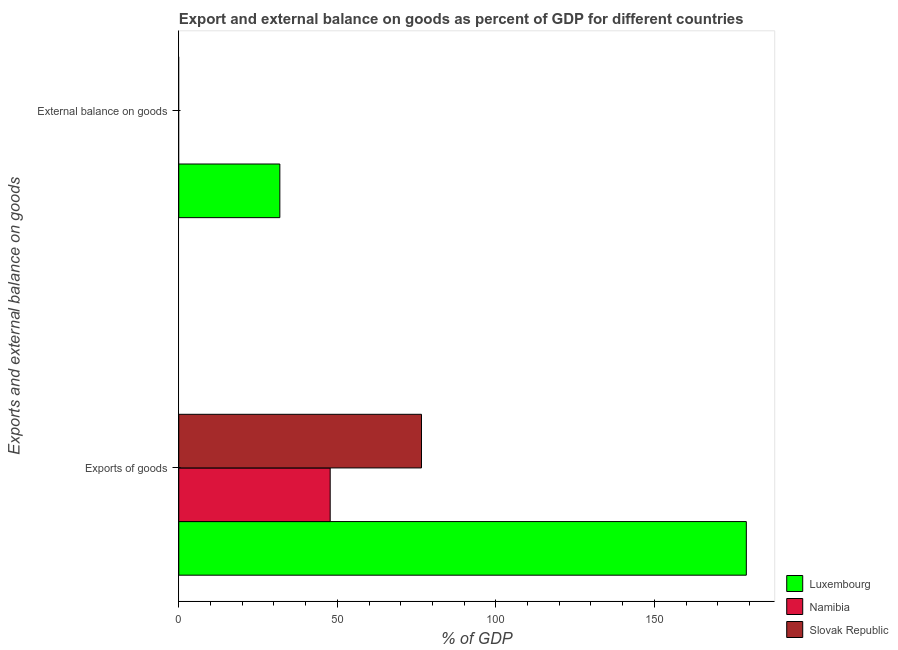Are the number of bars on each tick of the Y-axis equal?
Make the answer very short. No. How many bars are there on the 2nd tick from the top?
Keep it short and to the point. 3. What is the label of the 1st group of bars from the top?
Your answer should be compact. External balance on goods. What is the export of goods as percentage of gdp in Slovak Republic?
Offer a very short reply. 76.55. Across all countries, what is the maximum external balance on goods as percentage of gdp?
Offer a very short reply. 31.88. Across all countries, what is the minimum external balance on goods as percentage of gdp?
Provide a short and direct response. 0. In which country was the export of goods as percentage of gdp maximum?
Your answer should be very brief. Luxembourg. What is the total export of goods as percentage of gdp in the graph?
Your answer should be very brief. 303.32. What is the difference between the export of goods as percentage of gdp in Slovak Republic and that in Luxembourg?
Your answer should be compact. -102.46. What is the difference between the external balance on goods as percentage of gdp in Luxembourg and the export of goods as percentage of gdp in Namibia?
Provide a short and direct response. -15.88. What is the average export of goods as percentage of gdp per country?
Provide a short and direct response. 101.11. What is the difference between the external balance on goods as percentage of gdp and export of goods as percentage of gdp in Luxembourg?
Give a very brief answer. -147.13. What is the ratio of the export of goods as percentage of gdp in Slovak Republic to that in Namibia?
Give a very brief answer. 1.6. Is the export of goods as percentage of gdp in Namibia less than that in Luxembourg?
Your response must be concise. Yes. Are all the bars in the graph horizontal?
Give a very brief answer. Yes. Are the values on the major ticks of X-axis written in scientific E-notation?
Give a very brief answer. No. Does the graph contain any zero values?
Your response must be concise. Yes. How are the legend labels stacked?
Keep it short and to the point. Vertical. What is the title of the graph?
Your response must be concise. Export and external balance on goods as percent of GDP for different countries. What is the label or title of the X-axis?
Your answer should be compact. % of GDP. What is the label or title of the Y-axis?
Provide a short and direct response. Exports and external balance on goods. What is the % of GDP of Luxembourg in Exports of goods?
Ensure brevity in your answer.  179.01. What is the % of GDP of Namibia in Exports of goods?
Offer a very short reply. 47.76. What is the % of GDP in Slovak Republic in Exports of goods?
Offer a very short reply. 76.55. What is the % of GDP in Luxembourg in External balance on goods?
Provide a succinct answer. 31.88. What is the % of GDP of Namibia in External balance on goods?
Ensure brevity in your answer.  0. What is the % of GDP in Slovak Republic in External balance on goods?
Offer a terse response. 0. Across all Exports and external balance on goods, what is the maximum % of GDP of Luxembourg?
Offer a very short reply. 179.01. Across all Exports and external balance on goods, what is the maximum % of GDP in Namibia?
Make the answer very short. 47.76. Across all Exports and external balance on goods, what is the maximum % of GDP in Slovak Republic?
Offer a very short reply. 76.55. Across all Exports and external balance on goods, what is the minimum % of GDP in Luxembourg?
Ensure brevity in your answer.  31.88. Across all Exports and external balance on goods, what is the minimum % of GDP of Namibia?
Make the answer very short. 0. What is the total % of GDP in Luxembourg in the graph?
Make the answer very short. 210.89. What is the total % of GDP of Namibia in the graph?
Provide a short and direct response. 47.76. What is the total % of GDP in Slovak Republic in the graph?
Make the answer very short. 76.55. What is the difference between the % of GDP of Luxembourg in Exports of goods and that in External balance on goods?
Give a very brief answer. 147.13. What is the average % of GDP of Luxembourg per Exports and external balance on goods?
Offer a very short reply. 105.44. What is the average % of GDP of Namibia per Exports and external balance on goods?
Provide a short and direct response. 23.88. What is the average % of GDP in Slovak Republic per Exports and external balance on goods?
Provide a short and direct response. 38.28. What is the difference between the % of GDP in Luxembourg and % of GDP in Namibia in Exports of goods?
Your answer should be very brief. 131.25. What is the difference between the % of GDP of Luxembourg and % of GDP of Slovak Republic in Exports of goods?
Provide a short and direct response. 102.46. What is the difference between the % of GDP in Namibia and % of GDP in Slovak Republic in Exports of goods?
Your response must be concise. -28.79. What is the ratio of the % of GDP of Luxembourg in Exports of goods to that in External balance on goods?
Give a very brief answer. 5.62. What is the difference between the highest and the second highest % of GDP in Luxembourg?
Your answer should be compact. 147.13. What is the difference between the highest and the lowest % of GDP of Luxembourg?
Make the answer very short. 147.13. What is the difference between the highest and the lowest % of GDP in Namibia?
Provide a succinct answer. 47.76. What is the difference between the highest and the lowest % of GDP of Slovak Republic?
Your answer should be very brief. 76.55. 